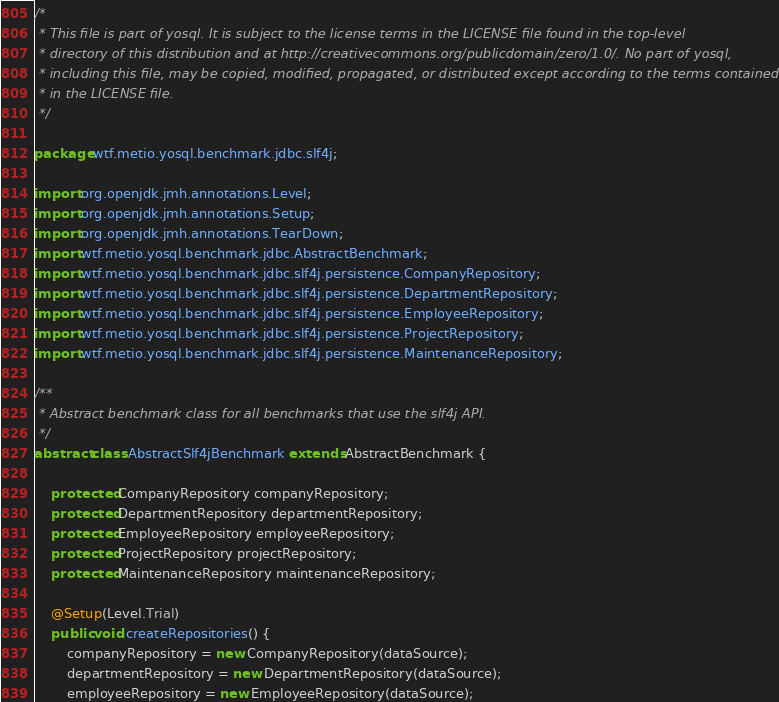Convert code to text. <code><loc_0><loc_0><loc_500><loc_500><_Java_>/*
 * This file is part of yosql. It is subject to the license terms in the LICENSE file found in the top-level
 * directory of this distribution and at http://creativecommons.org/publicdomain/zero/1.0/. No part of yosql,
 * including this file, may be copied, modified, propagated, or distributed except according to the terms contained
 * in the LICENSE file.
 */

package wtf.metio.yosql.benchmark.jdbc.slf4j;

import org.openjdk.jmh.annotations.Level;
import org.openjdk.jmh.annotations.Setup;
import org.openjdk.jmh.annotations.TearDown;
import wtf.metio.yosql.benchmark.jdbc.AbstractBenchmark;
import wtf.metio.yosql.benchmark.jdbc.slf4j.persistence.CompanyRepository;
import wtf.metio.yosql.benchmark.jdbc.slf4j.persistence.DepartmentRepository;
import wtf.metio.yosql.benchmark.jdbc.slf4j.persistence.EmployeeRepository;
import wtf.metio.yosql.benchmark.jdbc.slf4j.persistence.ProjectRepository;
import wtf.metio.yosql.benchmark.jdbc.slf4j.persistence.MaintenanceRepository;

/**
 * Abstract benchmark class for all benchmarks that use the slf4j API.
 */
abstract class AbstractSlf4jBenchmark extends AbstractBenchmark {

    protected CompanyRepository companyRepository;
    protected DepartmentRepository departmentRepository;
    protected EmployeeRepository employeeRepository;
    protected ProjectRepository projectRepository;
    protected MaintenanceRepository maintenanceRepository;

    @Setup(Level.Trial)
    public void createRepositories() {
        companyRepository = new CompanyRepository(dataSource);
        departmentRepository = new DepartmentRepository(dataSource);
        employeeRepository = new EmployeeRepository(dataSource);</code> 